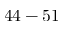<formula> <loc_0><loc_0><loc_500><loc_500>4 4 - 5 1</formula> 